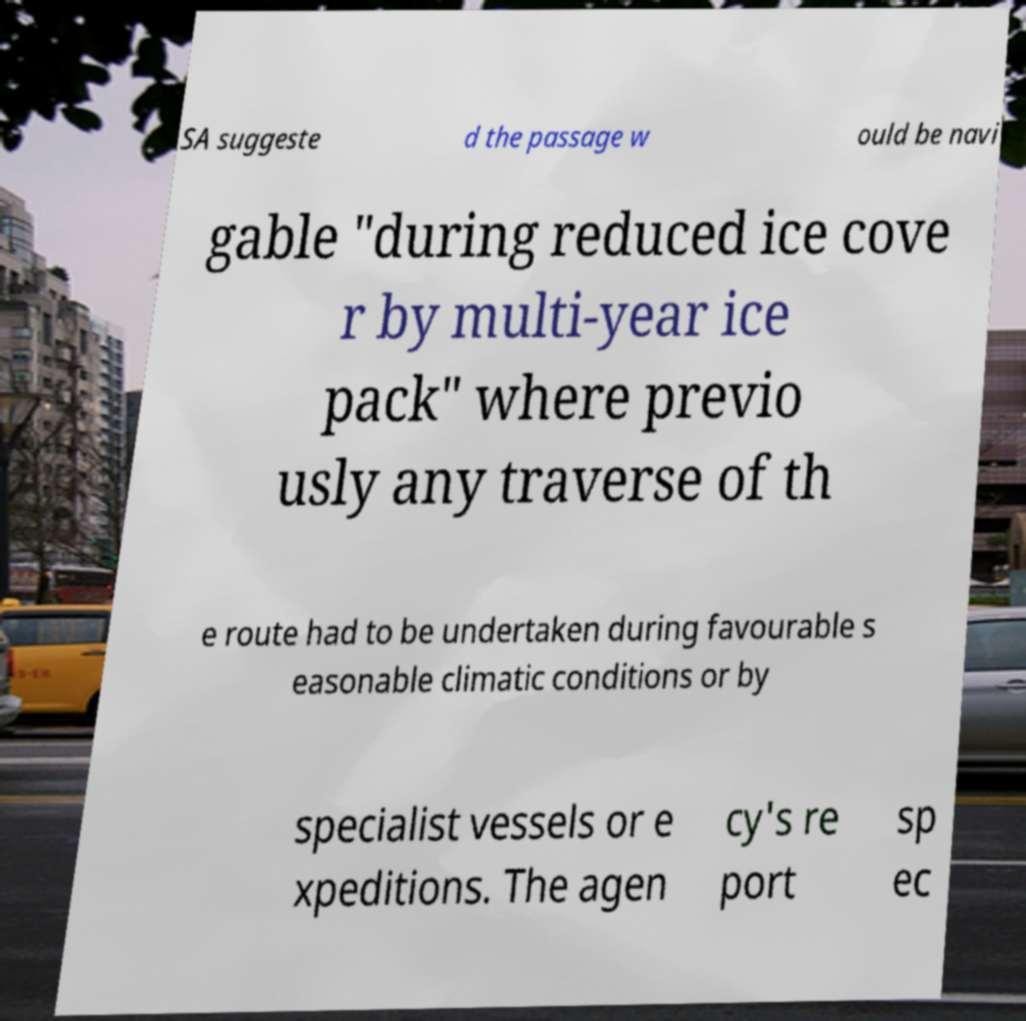What messages or text are displayed in this image? I need them in a readable, typed format. SA suggeste d the passage w ould be navi gable "during reduced ice cove r by multi-year ice pack" where previo usly any traverse of th e route had to be undertaken during favourable s easonable climatic conditions or by specialist vessels or e xpeditions. The agen cy's re port sp ec 